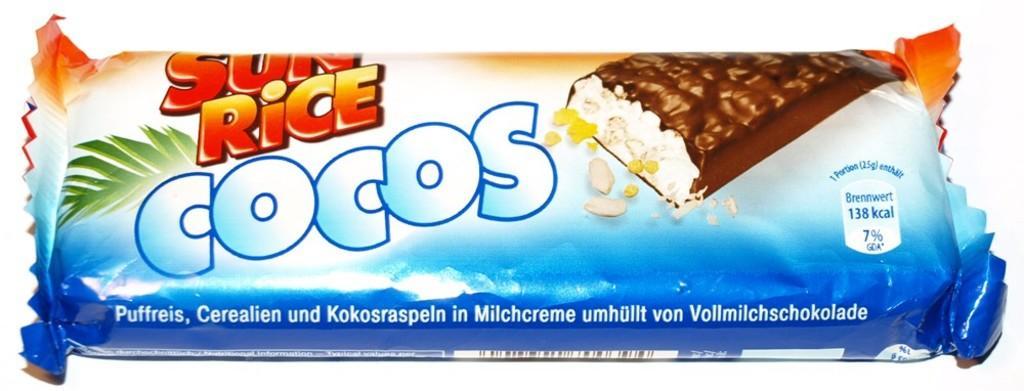In one or two sentences, can you explain what this image depicts? In this image we can see the cover of a chocolate with some text, a barcode and some pictures on it. 